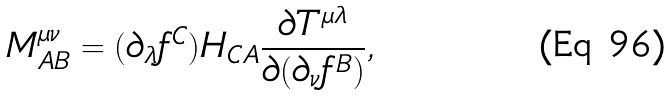Convert formula to latex. <formula><loc_0><loc_0><loc_500><loc_500>M ^ { \mu \nu } _ { A B } = ( \partial _ { \lambda } f ^ { C } ) H _ { C A } \frac { \partial T ^ { \mu \lambda } } { \partial ( \partial _ { \nu } f ^ { B } ) } ,</formula> 